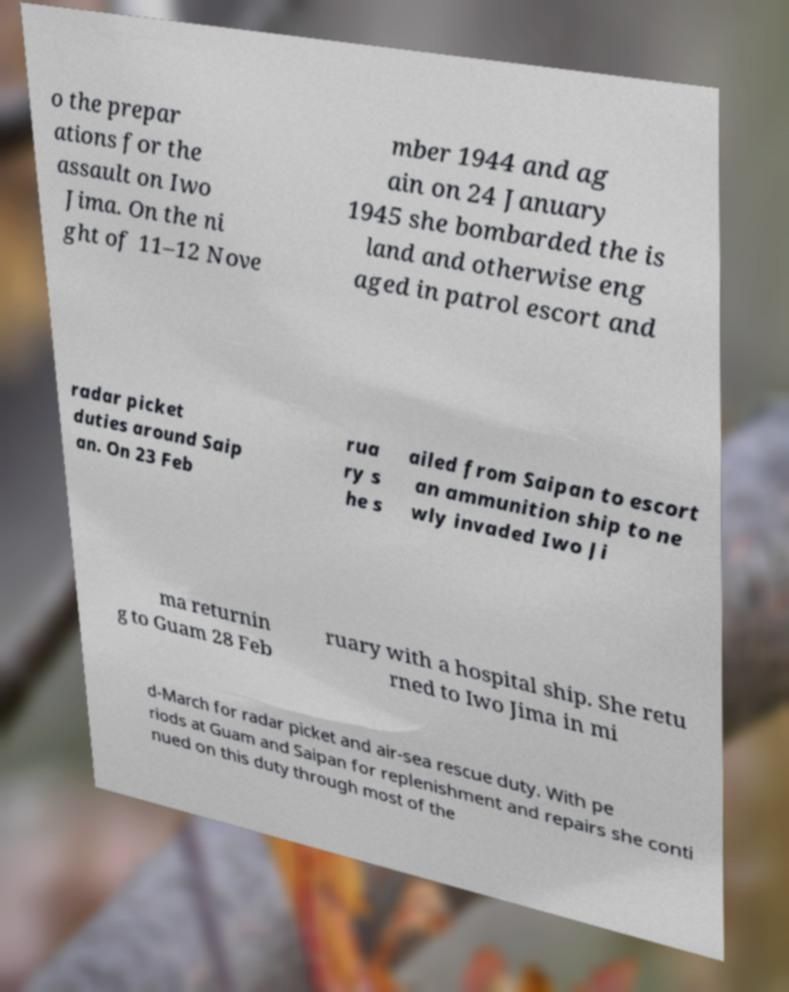Can you read and provide the text displayed in the image?This photo seems to have some interesting text. Can you extract and type it out for me? o the prepar ations for the assault on Iwo Jima. On the ni ght of 11–12 Nove mber 1944 and ag ain on 24 January 1945 she bombarded the is land and otherwise eng aged in patrol escort and radar picket duties around Saip an. On 23 Feb rua ry s he s ailed from Saipan to escort an ammunition ship to ne wly invaded Iwo Ji ma returnin g to Guam 28 Feb ruary with a hospital ship. She retu rned to Iwo Jima in mi d-March for radar picket and air-sea rescue duty. With pe riods at Guam and Saipan for replenishment and repairs she conti nued on this duty through most of the 